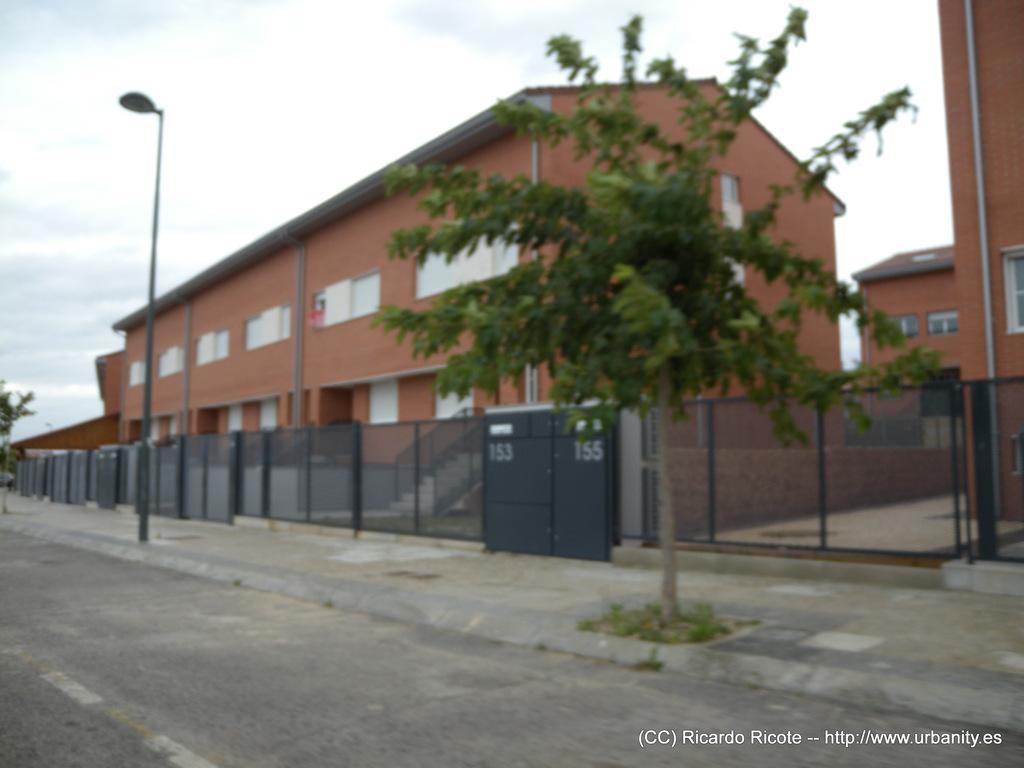Please provide a concise description of this image. In this picture we can see the road, footpath, fence, trees, buildings with windows, pipes, street light pole and in the background we can see the sky with clouds. 